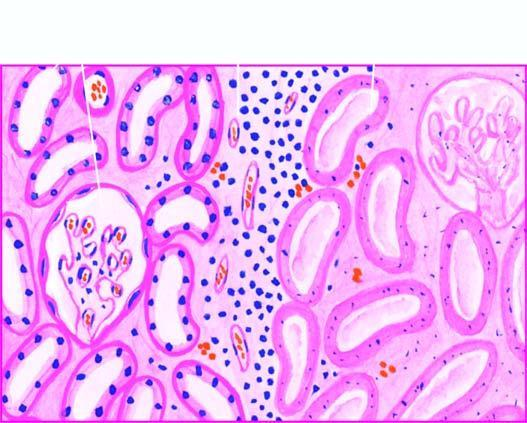what does the interface between viable and non-viable area show?
Answer the question using a single word or phrase. Non-specific chronic inflammation proliferating vessels 